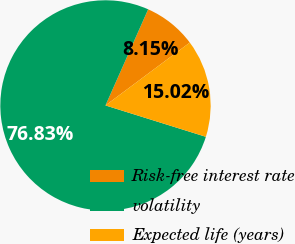Convert chart to OTSL. <chart><loc_0><loc_0><loc_500><loc_500><pie_chart><fcel>Risk-free interest rate<fcel>volatility<fcel>Expected life (years)<nl><fcel>8.15%<fcel>76.83%<fcel>15.02%<nl></chart> 